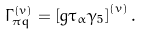<formula> <loc_0><loc_0><loc_500><loc_500>\Gamma ^ { \left ( v \right ) } _ { \pi q } = \left [ g \tau _ { \alpha } \gamma _ { 5 } \right ] ^ { \left ( v \right ) } .</formula> 